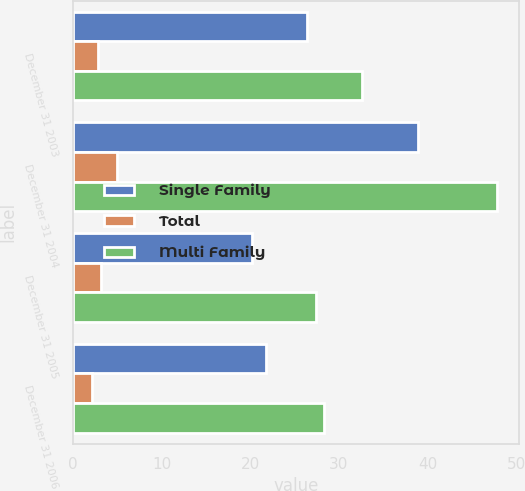<chart> <loc_0><loc_0><loc_500><loc_500><stacked_bar_chart><ecel><fcel>December 31 2003<fcel>December 31 2004<fcel>December 31 2005<fcel>December 31 2006<nl><fcel>Single Family<fcel>26.4<fcel>38.9<fcel>20.2<fcel>21.8<nl><fcel>Total<fcel>2.8<fcel>5<fcel>3.2<fcel>2.1<nl><fcel>Multi Family<fcel>32.6<fcel>47.9<fcel>27.4<fcel>28.3<nl></chart> 